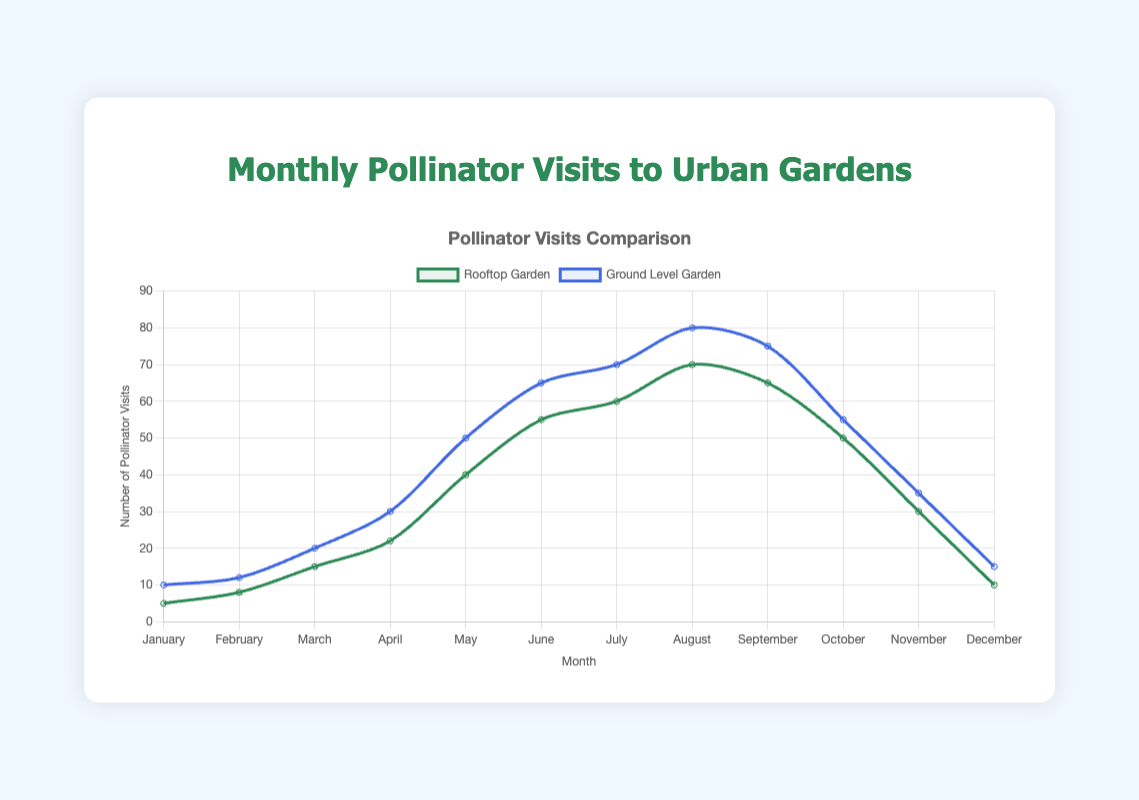What month had the highest number of pollinator visits in the rooftop garden? Look at the peak of the green line representing "Rooftop Garden". Identify the corresponding month.
Answer: August How many more pollinator visits were there in June for the ground-level garden compared to the rooftop garden? Find the values for June: Ground Level Garden (65 visits), Rooftop Garden (55 visits). Subtract the rooftop value from the ground-level value: 65 - 55.
Answer: 10 During which month is the difference in pollinator visits between the rooftop garden and ground-level garden smallest? Check the differences for each month: January (5), February (4), March (5), April (8), May (10), June (10), July (10), August (10), September (10), October (5), November (5), December (5). The smallest difference is in February (4).
Answer: February On average, how many pollinator visits occurred per month in the rooftop garden between May and August? Sum the pollinator visits from May to August for the "Rooftop Garden" (40 + 55 + 60 + 70 = 225). Divide by 4 (months).
Answer: 56.25 Which garden had more variability in pollinator visits over the year, and how do you know? Compare the range of pollinator visits in each garden. Rooftop Garden: max (70) - min (5) = 65. Ground-Level Garden: max (80) - min (10) = 70. Thus, the ground-level garden had more variability.
Answer: Ground-Level Garden For which months were pollinator visits higher in the rooftop garden compared to the ground-level garden? Compare the values for both gardens each month: select the months where the rooftop values exceed ground-level values. No months meet this criterion.
Answer: None What is the sum of pollinator visits in both gardens in October? Add the visits in October for the "Rooftop Garden" (50) and "Ground-Level Garden" (55).
Answer: 105 In which season (Winter: Dec-Feb, Spring: Mar-May, Summer: Jun-Aug, Fall: Sep-Nov) did the rooftop garden see the steepest rise in pollinator visits? Observe the slope of the green line. The steepest rise is from April to May, hence it is in Spring.
Answer: Spring How does the number of pollinator visits in January compare between the two gardens? Look at January for both gardens: Rooftop Garden (5 visits), Ground-Level Garden (10 visits). Compare these values.
Answer: Ground-Level has more What is the average number of pollinator visits per month for the ground-level garden? Add the monthly values for the "Ground-Level Garden" (10 + 12 + 20 + 30 + 50 + 65 + 70 + 80 + 75 + 55 + 35 + 15 = 517). Divide by 12 months.
Answer: 43.08 